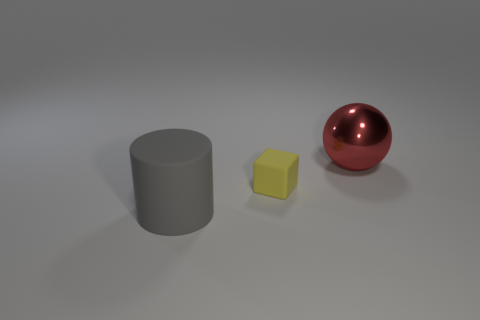Do the large cylinder and the thing behind the tiny block have the same color?
Your response must be concise. No. Is the number of big red metal things that are left of the red shiny sphere the same as the number of red metal things that are on the left side of the tiny yellow matte block?
Provide a succinct answer. Yes. What is the material of the large thing that is behind the small yellow rubber object?
Ensure brevity in your answer.  Metal. What number of things are either matte objects on the left side of the yellow rubber block or matte objects?
Keep it short and to the point. 2. What number of other objects are there of the same shape as the tiny thing?
Keep it short and to the point. 0. There is a thing that is in front of the yellow rubber thing; does it have the same shape as the yellow thing?
Make the answer very short. No. Are there any red things in front of the large ball?
Provide a short and direct response. No. How many big things are either yellow spheres or yellow blocks?
Your response must be concise. 0. Is the material of the big gray thing the same as the red thing?
Offer a very short reply. No. Are there any other large rubber cylinders that have the same color as the cylinder?
Keep it short and to the point. No. 